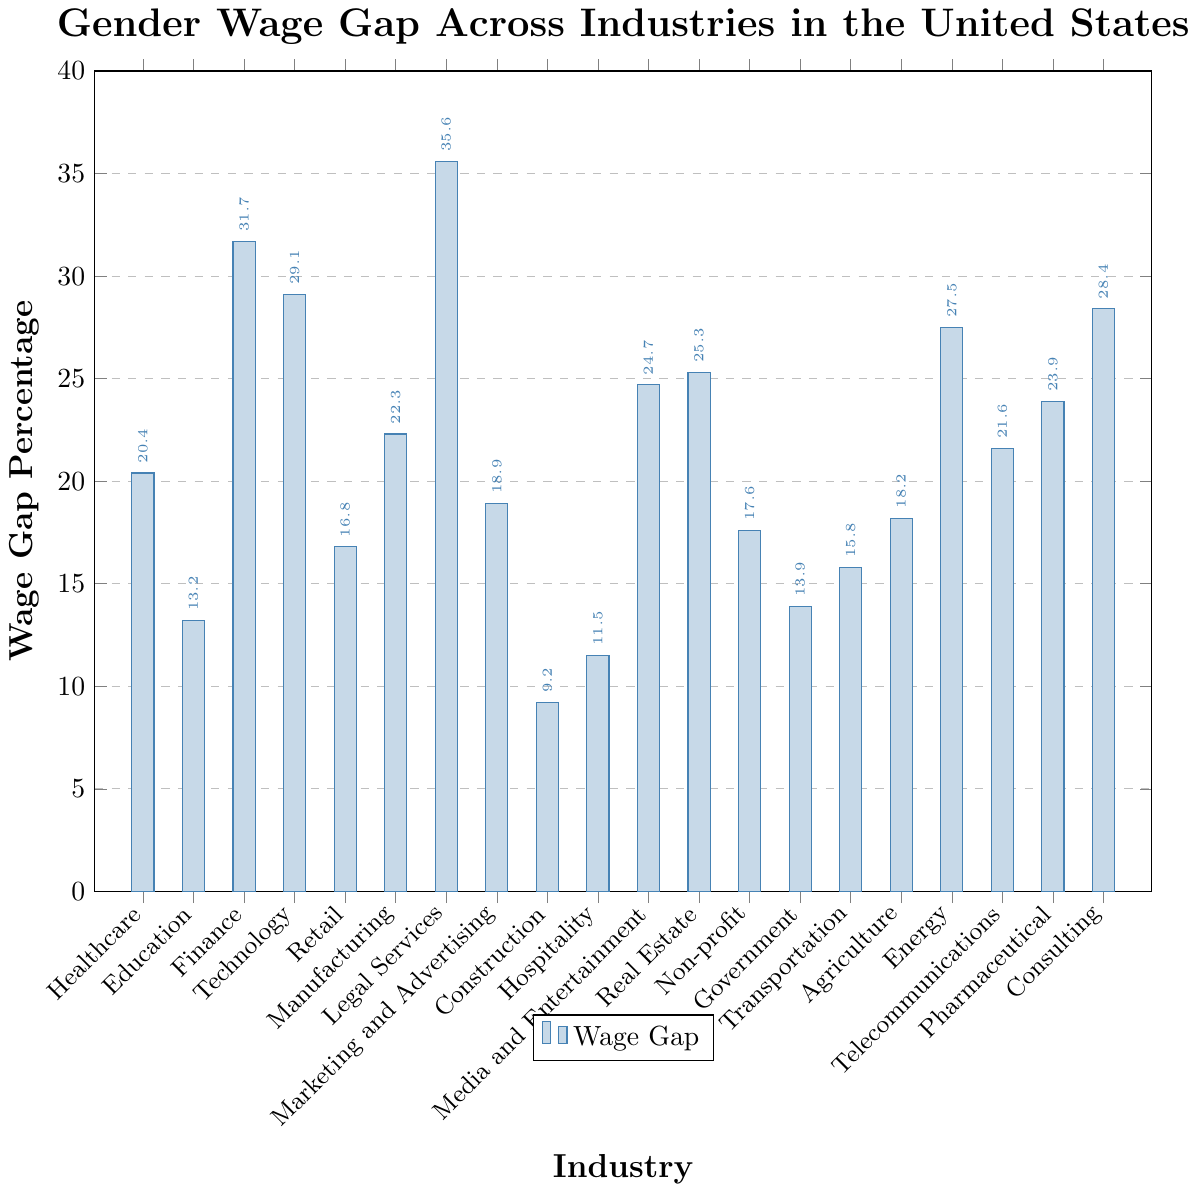Which industry has the highest gender wage gap? The highest bar in the chart represents the industry with the largest wage gap, which is labeled as Legal Services with a wage gap percentage of 35.6%.
Answer: Legal Services Which industry has the lowest gender wage gap? The smallest bar in the chart represents the industry with the lowest wage gap, which is labeled as Construction with a wage gap percentage of 9.2%.
Answer: Construction What is the wage gap in the Finance industry? Locate the bar labeled Finance and check the height of the bar, which has a label showing the wage gap percentage of 31.7%.
Answer: 31.7% How do the wage gaps in Healthcare and Technology compare? Locate the bars for Healthcare and Technology, then compare their respective heights. The Healthcare bar is at 20.4%, and the Technology bar is at 29.1%. Therefore, Technology has a higher wage gap.
Answer: Technology has a higher wage gap What is the average wage gap among all the industries? To find the average wage gap, sum all wage gap percentages and divide by the number of industries: (20.4 + 13.2 + 31.7 + 29.1 + 16.8 + 22.3 + 35.6 + 18.9 + 9.2 + 11.5 + 24.7 + 25.3 + 17.6 + 13.9 + 15.8 + 18.2 + 27.5 + 21.6 + 23.9 + 28.4) / 20 = 21.125%.
Answer: 21.125% By how much does the wage gap in Legal Services exceed that in Construction? Subtract the wage gap percentage of Construction from that of Legal Services: 35.6% - 9.2% = 26.4%.
Answer: 26.4% What are the industries with a wage gap percentage over 25%? Identify all bars with heights exceeding 25%. These are Legal Services (35.6%), Finance (31.7%), Technology (29.1%), Real Estate (25.3%), and Consulting (28.4%).
Answer: Legal Services, Finance, Technology, Real Estate, Consulting How does the wage gap in Marketing and Advertising compare to that in Transportation? Locate the bars for Marketing and Advertising (18.9%) and Transportation (15.8%). Marketing and Advertising has a higher wage gap compared to Transportation.
Answer: Marketing and Advertising has a higher wage gap Which two industries have the closest wage gap percentages? Identify the two bars that are closest in height. Education (13.2%) and Government (13.9%) are very close in percentage, differing by only 0.7%.
Answer: Education and Government What is the median wage gap percentage of the industries shown? Sort the wage gap percentages in ascending order and find the middle value: (9.2, 11.5, 13.2, 13.9, 15.8, 16.8, 17.6, 18.2, 18.9, 20.4, 21.6, 22.3, 23.9, 24.7, 25.3, 27.5, 28.4, 29.1, 31.7, 35.6). With 20 data points, the median is the average of the 10th and 11th values: (20.4 + 21.6) / 2 = 21.0%.
Answer: 21.0% 